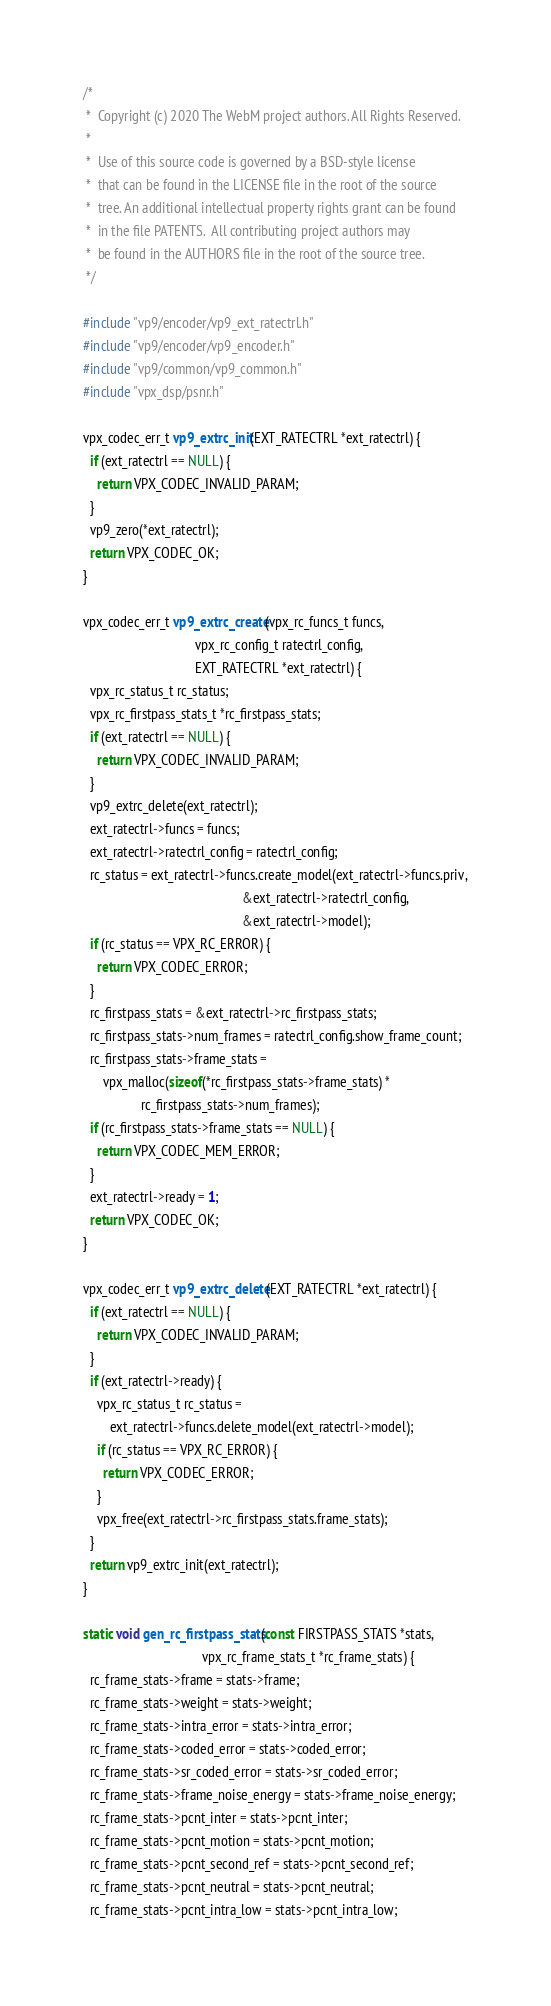Convert code to text. <code><loc_0><loc_0><loc_500><loc_500><_C_>/*
 *  Copyright (c) 2020 The WebM project authors. All Rights Reserved.
 *
 *  Use of this source code is governed by a BSD-style license
 *  that can be found in the LICENSE file in the root of the source
 *  tree. An additional intellectual property rights grant can be found
 *  in the file PATENTS.  All contributing project authors may
 *  be found in the AUTHORS file in the root of the source tree.
 */

#include "vp9/encoder/vp9_ext_ratectrl.h"
#include "vp9/encoder/vp9_encoder.h"
#include "vp9/common/vp9_common.h"
#include "vpx_dsp/psnr.h"

vpx_codec_err_t vp9_extrc_init(EXT_RATECTRL *ext_ratectrl) {
  if (ext_ratectrl == NULL) {
    return VPX_CODEC_INVALID_PARAM;
  }
  vp9_zero(*ext_ratectrl);
  return VPX_CODEC_OK;
}

vpx_codec_err_t vp9_extrc_create(vpx_rc_funcs_t funcs,
                                 vpx_rc_config_t ratectrl_config,
                                 EXT_RATECTRL *ext_ratectrl) {
  vpx_rc_status_t rc_status;
  vpx_rc_firstpass_stats_t *rc_firstpass_stats;
  if (ext_ratectrl == NULL) {
    return VPX_CODEC_INVALID_PARAM;
  }
  vp9_extrc_delete(ext_ratectrl);
  ext_ratectrl->funcs = funcs;
  ext_ratectrl->ratectrl_config = ratectrl_config;
  rc_status = ext_ratectrl->funcs.create_model(ext_ratectrl->funcs.priv,
                                               &ext_ratectrl->ratectrl_config,
                                               &ext_ratectrl->model);
  if (rc_status == VPX_RC_ERROR) {
    return VPX_CODEC_ERROR;
  }
  rc_firstpass_stats = &ext_ratectrl->rc_firstpass_stats;
  rc_firstpass_stats->num_frames = ratectrl_config.show_frame_count;
  rc_firstpass_stats->frame_stats =
      vpx_malloc(sizeof(*rc_firstpass_stats->frame_stats) *
                 rc_firstpass_stats->num_frames);
  if (rc_firstpass_stats->frame_stats == NULL) {
    return VPX_CODEC_MEM_ERROR;
  }
  ext_ratectrl->ready = 1;
  return VPX_CODEC_OK;
}

vpx_codec_err_t vp9_extrc_delete(EXT_RATECTRL *ext_ratectrl) {
  if (ext_ratectrl == NULL) {
    return VPX_CODEC_INVALID_PARAM;
  }
  if (ext_ratectrl->ready) {
    vpx_rc_status_t rc_status =
        ext_ratectrl->funcs.delete_model(ext_ratectrl->model);
    if (rc_status == VPX_RC_ERROR) {
      return VPX_CODEC_ERROR;
    }
    vpx_free(ext_ratectrl->rc_firstpass_stats.frame_stats);
  }
  return vp9_extrc_init(ext_ratectrl);
}

static void gen_rc_firstpass_stats(const FIRSTPASS_STATS *stats,
                                   vpx_rc_frame_stats_t *rc_frame_stats) {
  rc_frame_stats->frame = stats->frame;
  rc_frame_stats->weight = stats->weight;
  rc_frame_stats->intra_error = stats->intra_error;
  rc_frame_stats->coded_error = stats->coded_error;
  rc_frame_stats->sr_coded_error = stats->sr_coded_error;
  rc_frame_stats->frame_noise_energy = stats->frame_noise_energy;
  rc_frame_stats->pcnt_inter = stats->pcnt_inter;
  rc_frame_stats->pcnt_motion = stats->pcnt_motion;
  rc_frame_stats->pcnt_second_ref = stats->pcnt_second_ref;
  rc_frame_stats->pcnt_neutral = stats->pcnt_neutral;
  rc_frame_stats->pcnt_intra_low = stats->pcnt_intra_low;</code> 